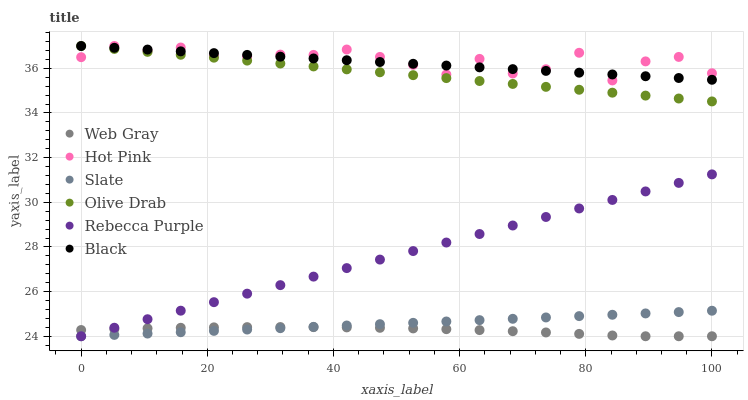Does Web Gray have the minimum area under the curve?
Answer yes or no. Yes. Does Hot Pink have the maximum area under the curve?
Answer yes or no. Yes. Does Slate have the minimum area under the curve?
Answer yes or no. No. Does Slate have the maximum area under the curve?
Answer yes or no. No. Is Black the smoothest?
Answer yes or no. Yes. Is Hot Pink the roughest?
Answer yes or no. Yes. Is Slate the smoothest?
Answer yes or no. No. Is Slate the roughest?
Answer yes or no. No. Does Web Gray have the lowest value?
Answer yes or no. Yes. Does Hot Pink have the lowest value?
Answer yes or no. No. Does Olive Drab have the highest value?
Answer yes or no. Yes. Does Slate have the highest value?
Answer yes or no. No. Is Rebecca Purple less than Hot Pink?
Answer yes or no. Yes. Is Olive Drab greater than Web Gray?
Answer yes or no. Yes. Does Black intersect Olive Drab?
Answer yes or no. Yes. Is Black less than Olive Drab?
Answer yes or no. No. Is Black greater than Olive Drab?
Answer yes or no. No. Does Rebecca Purple intersect Hot Pink?
Answer yes or no. No. 